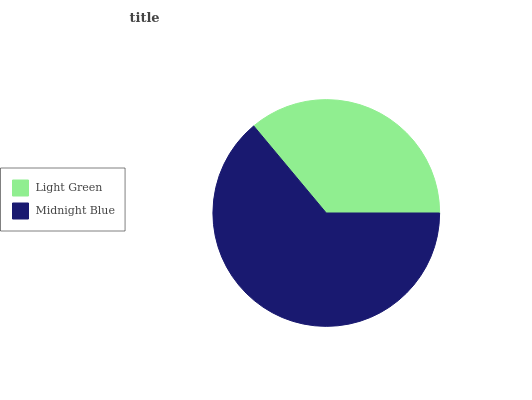Is Light Green the minimum?
Answer yes or no. Yes. Is Midnight Blue the maximum?
Answer yes or no. Yes. Is Midnight Blue the minimum?
Answer yes or no. No. Is Midnight Blue greater than Light Green?
Answer yes or no. Yes. Is Light Green less than Midnight Blue?
Answer yes or no. Yes. Is Light Green greater than Midnight Blue?
Answer yes or no. No. Is Midnight Blue less than Light Green?
Answer yes or no. No. Is Midnight Blue the high median?
Answer yes or no. Yes. Is Light Green the low median?
Answer yes or no. Yes. Is Light Green the high median?
Answer yes or no. No. Is Midnight Blue the low median?
Answer yes or no. No. 